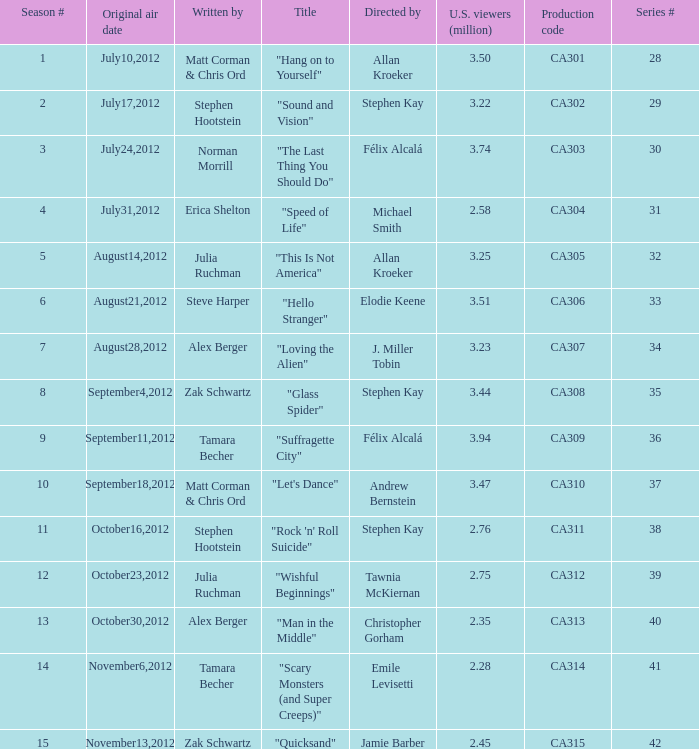Who directed the episode with production code ca303? Félix Alcalá. 